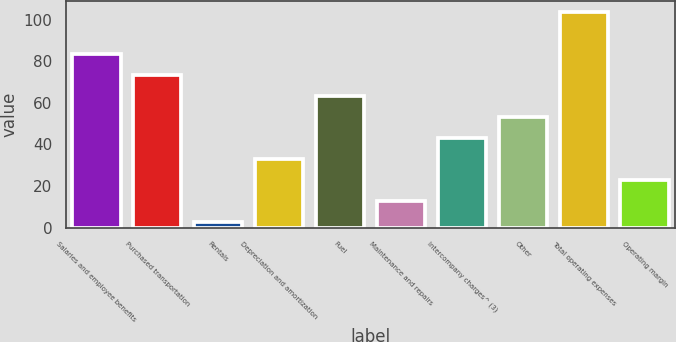<chart> <loc_0><loc_0><loc_500><loc_500><bar_chart><fcel>Salaries and employee benefits<fcel>Purchased transportation<fcel>Rentals<fcel>Depreciation and amortization<fcel>Fuel<fcel>Maintenance and repairs<fcel>Intercompany charges^ (3)<fcel>Other<fcel>Total operating expenses<fcel>Operating margin<nl><fcel>83.34<fcel>73.26<fcel>2.7<fcel>32.94<fcel>63.18<fcel>12.78<fcel>43.02<fcel>53.1<fcel>103.5<fcel>22.86<nl></chart> 